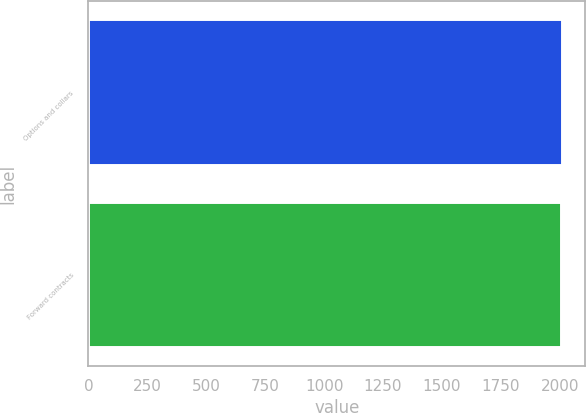<chart> <loc_0><loc_0><loc_500><loc_500><bar_chart><fcel>Options and collars<fcel>Forward contracts<nl><fcel>2007<fcel>2006<nl></chart> 